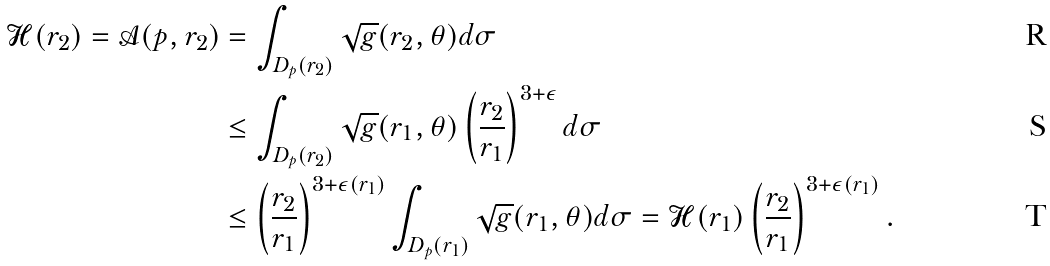Convert formula to latex. <formula><loc_0><loc_0><loc_500><loc_500>\mathcal { H } ( r _ { 2 } ) = \mathcal { A } ( p , r _ { 2 } ) & = \int _ { D _ { p } ( r _ { 2 } ) } \sqrt { g } ( r _ { 2 } , \theta ) d \sigma \\ & \leq \int _ { D _ { p } ( r _ { 2 } ) } \sqrt { g } ( r _ { 1 } , \theta ) \left ( \frac { r _ { 2 } } { r _ { 1 } } \right ) ^ { 3 + \epsilon } d \sigma \\ & \leq \left ( \frac { r _ { 2 } } { r _ { 1 } } \right ) ^ { 3 + \epsilon ( r _ { 1 } ) } \int _ { D _ { p } ( r _ { 1 } ) } \sqrt { g } ( r _ { 1 } , \theta ) d \sigma = \mathcal { H } ( r _ { 1 } ) \left ( \frac { r _ { 2 } } { r _ { 1 } } \right ) ^ { 3 + \epsilon ( r _ { 1 } ) } .</formula> 